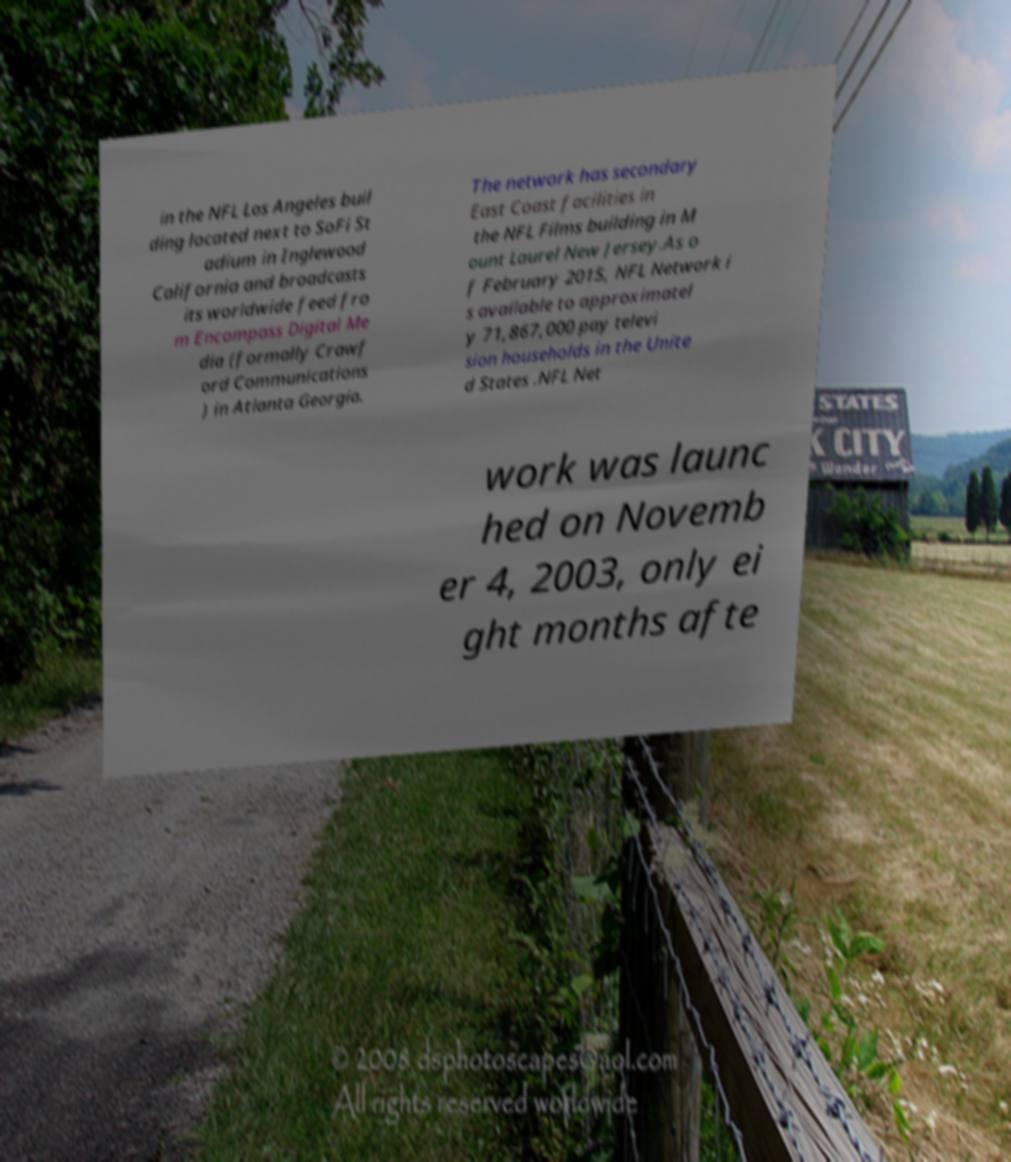Could you assist in decoding the text presented in this image and type it out clearly? in the NFL Los Angeles buil ding located next to SoFi St adium in Inglewood California and broadcasts its worldwide feed fro m Encompass Digital Me dia (formally Crawf ord Communications ) in Atlanta Georgia. The network has secondary East Coast facilities in the NFL Films building in M ount Laurel New Jersey.As o f February 2015, NFL Network i s available to approximatel y 71,867,000 pay televi sion households in the Unite d States .NFL Net work was launc hed on Novemb er 4, 2003, only ei ght months afte 